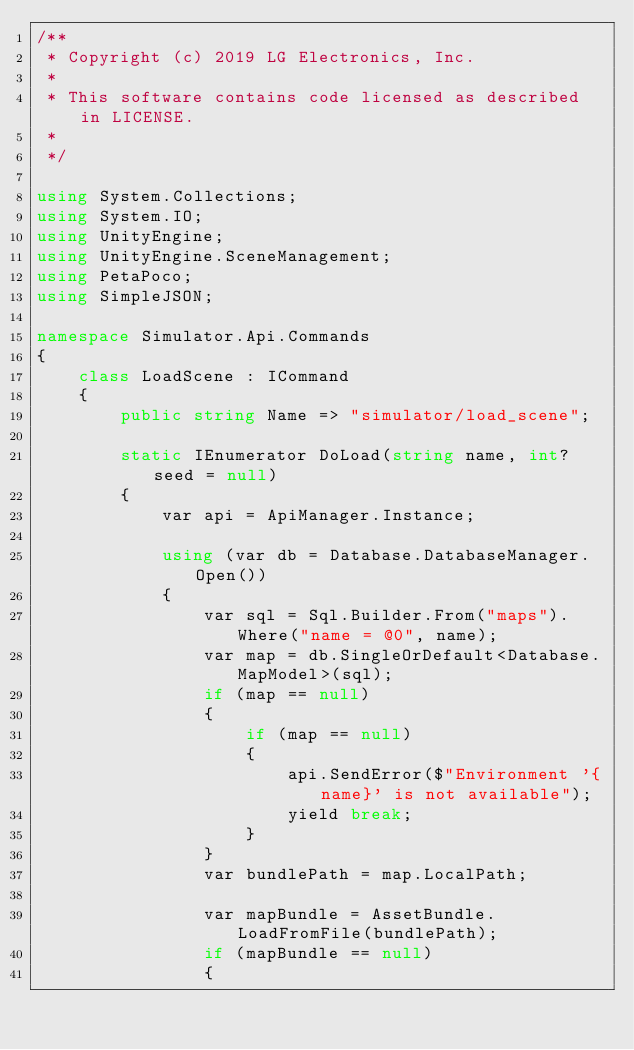<code> <loc_0><loc_0><loc_500><loc_500><_C#_>/**
 * Copyright (c) 2019 LG Electronics, Inc.
 *
 * This software contains code licensed as described in LICENSE.
 *
 */

using System.Collections;
using System.IO;
using UnityEngine;
using UnityEngine.SceneManagement;
using PetaPoco;
using SimpleJSON;

namespace Simulator.Api.Commands
{
    class LoadScene : ICommand
    {
        public string Name => "simulator/load_scene";
        
        static IEnumerator DoLoad(string name, int? seed = null)
        {
            var api = ApiManager.Instance;

            using (var db = Database.DatabaseManager.Open())
            {
                var sql = Sql.Builder.From("maps").Where("name = @0", name);
                var map = db.SingleOrDefault<Database.MapModel>(sql);
                if (map == null)
                {
                    if (map == null)
                    {
                        api.SendError($"Environment '{name}' is not available");
                        yield break;
                    }
                }
                var bundlePath = map.LocalPath;

                var mapBundle = AssetBundle.LoadFromFile(bundlePath);
                if (mapBundle == null)
                {</code> 